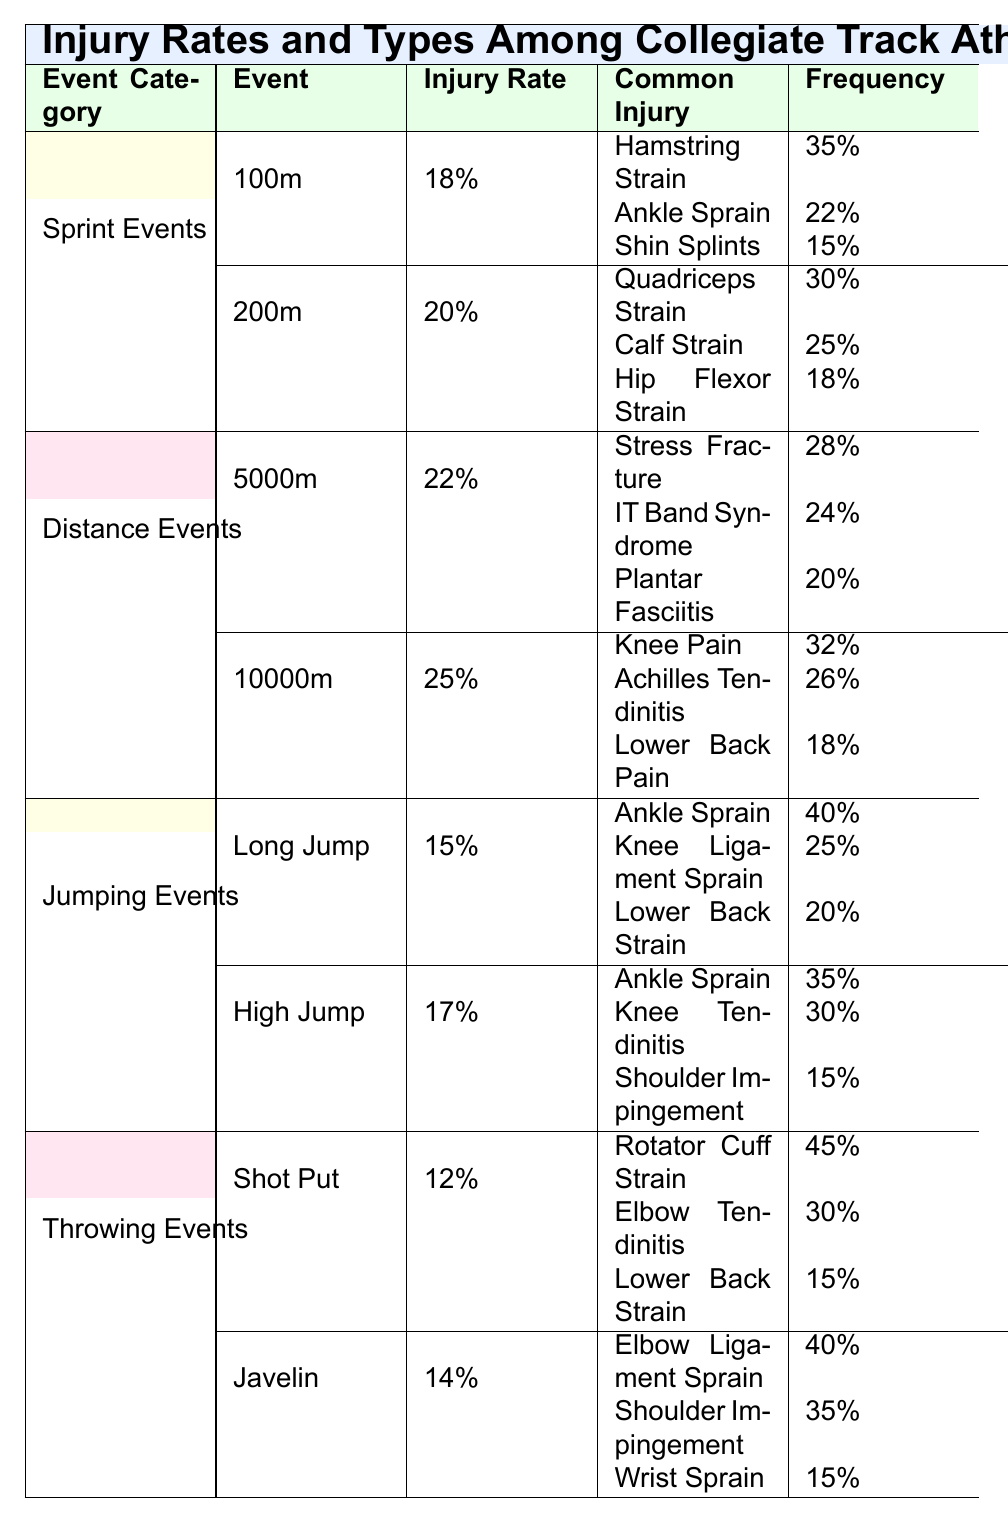What is the injury rate for the 200m sprint event? The injury rate for the 200m sprint event is explicitly listed in the table under Sprint Events for the 200m category. It is shown as 20%.
Answer: 20% Which common injury occurs most frequently in the 100m sprint event? In the 100m sprint event, the common injuries and their frequencies are listed. The injury with the highest frequency is the Hamstring Strain at 35%.
Answer: Hamstring Strain What is the difference in injury rates between the 5000m and 10000m distance events? The injury rate for the 5000m event is 22% and for the 10000m event is 25%. To find the difference, subtract the two rates: 25% - 22% = 3%.
Answer: 3% Which jumping event has the lowest injury rate? The injury rates for the jumping events are 15% for Long Jump and 17% for High Jump. Since 15% is lower than 17%, Long Jump has the lowest injury rate.
Answer: Long Jump Is the frequency of Ankle Sprain in Long Jump higher than in High Jump? In Long Jump, the frequency of Ankle Sprain is 40%, while in High Jump it is 35%. Since 40% is greater than 35%, the statement is true.
Answer: Yes What is the average frequency of common injuries for the 10000m event? The common injuries for the 10000m event are Knee Pain (32%), Achilles Tendinitis (26%), and Lower Back Pain (18%). To average these, sum them: 32% + 26% + 18% = 76%. Then divide by 3 (the number of injuries): 76% / 3 = 25.33%.
Answer: 25.33% Which event category has the highest average injury rate? The injury rates per category are: Sprint Events (19%), Distance Events (23.5%), Jumping Events (16%), and Throwing Events (13%). To find the averages, sum the rates for Sprint Events (18% + 20% = 38% / 2 = 19%), Distance Events (22% + 25% = 47% / 2 = 23.5%), Jumping Events (15% + 17% = 32% / 2 = 16%), and Throwing Events (12% + 14% = 26% / 2 = 13%). The highest average is for Distance Events at 23.5%.
Answer: Distance Events What percentage of Shot Put injuries are due to Rotator Cuff Strain? The common injuries for Shot Put are listed, with Rotator Cuff Strain occurring at a frequency of 45%. This value represents the percentage directly provided in the table.
Answer: 45% Are the common injuries for the Javelin event related to upper body injuries? The common injuries listed for Javelin are Elbow Ligament Sprain, Shoulder Impingement, and Wrist Sprain. These injuries all involve the upper body (elbow, shoulder, wrist), indicating that they are indeed upper body injuries.
Answer: Yes What type of injury is most frequently associated with the 10000m event? The common injuries for the 10000m event are Knee Pain (32%), Achilles Tendinitis (26%), and Lower Back Pain (18%). The most frequent injury is Knee Pain at 32%.
Answer: Knee Pain 